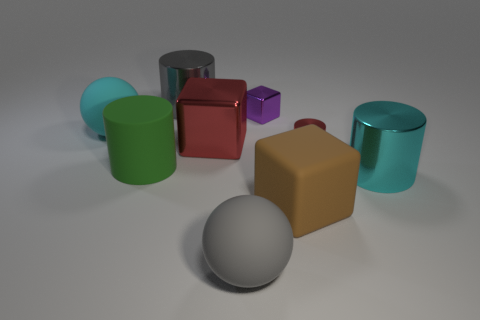What is the material of the large gray thing that is in front of the large rubber sphere that is behind the cyan shiny cylinder?
Keep it short and to the point. Rubber. What is the shape of the tiny red metal thing?
Make the answer very short. Cylinder. Are there the same number of cyan shiny cylinders to the left of the green matte object and large gray things that are behind the large cyan cylinder?
Your answer should be compact. No. Is the color of the matte sphere in front of the big matte cylinder the same as the big cube behind the green thing?
Ensure brevity in your answer.  No. Are there more red objects that are to the left of the tiny purple block than brown matte spheres?
Offer a terse response. Yes. There is a cyan thing that is made of the same material as the big green thing; what shape is it?
Ensure brevity in your answer.  Sphere. There is a matte ball in front of the rubber cube; is its size the same as the purple object?
Your answer should be compact. No. What shape is the large gray thing in front of the big metal thing on the right side of the brown thing?
Provide a succinct answer. Sphere. There is a gray thing to the left of the big ball that is to the right of the cyan ball; how big is it?
Offer a very short reply. Large. There is a metal cylinder that is behind the red cube; what color is it?
Your answer should be very brief. Gray. 